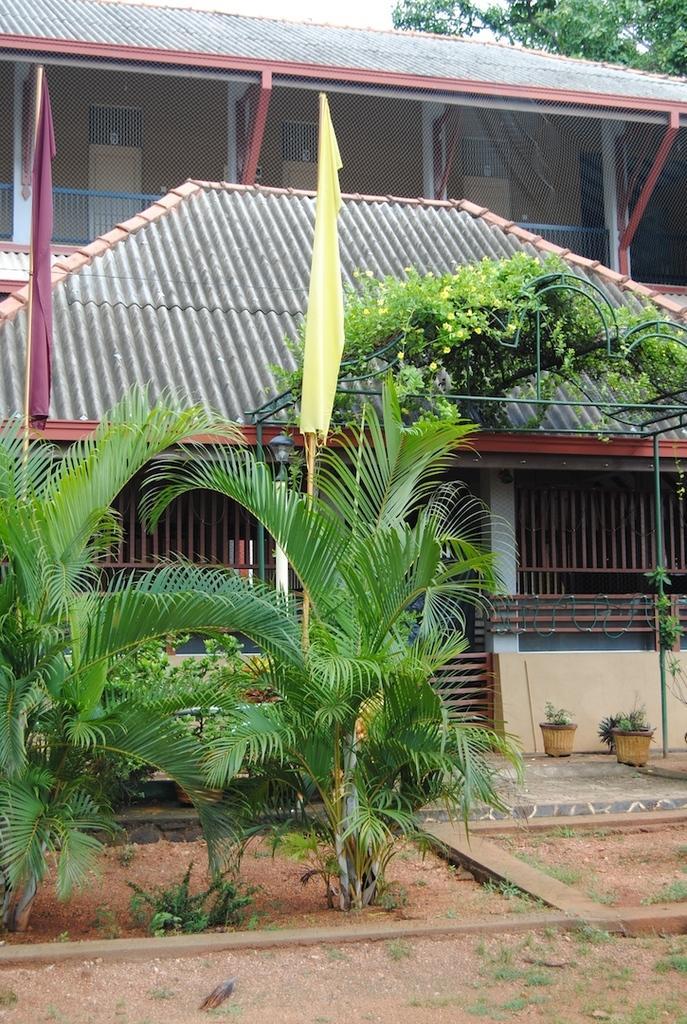How would you summarize this image in a sentence or two? In this picture we can observe a house. There are some plants on the ground. We can observe two flags which were in purple and yellow colors. In the background there is a tree. 